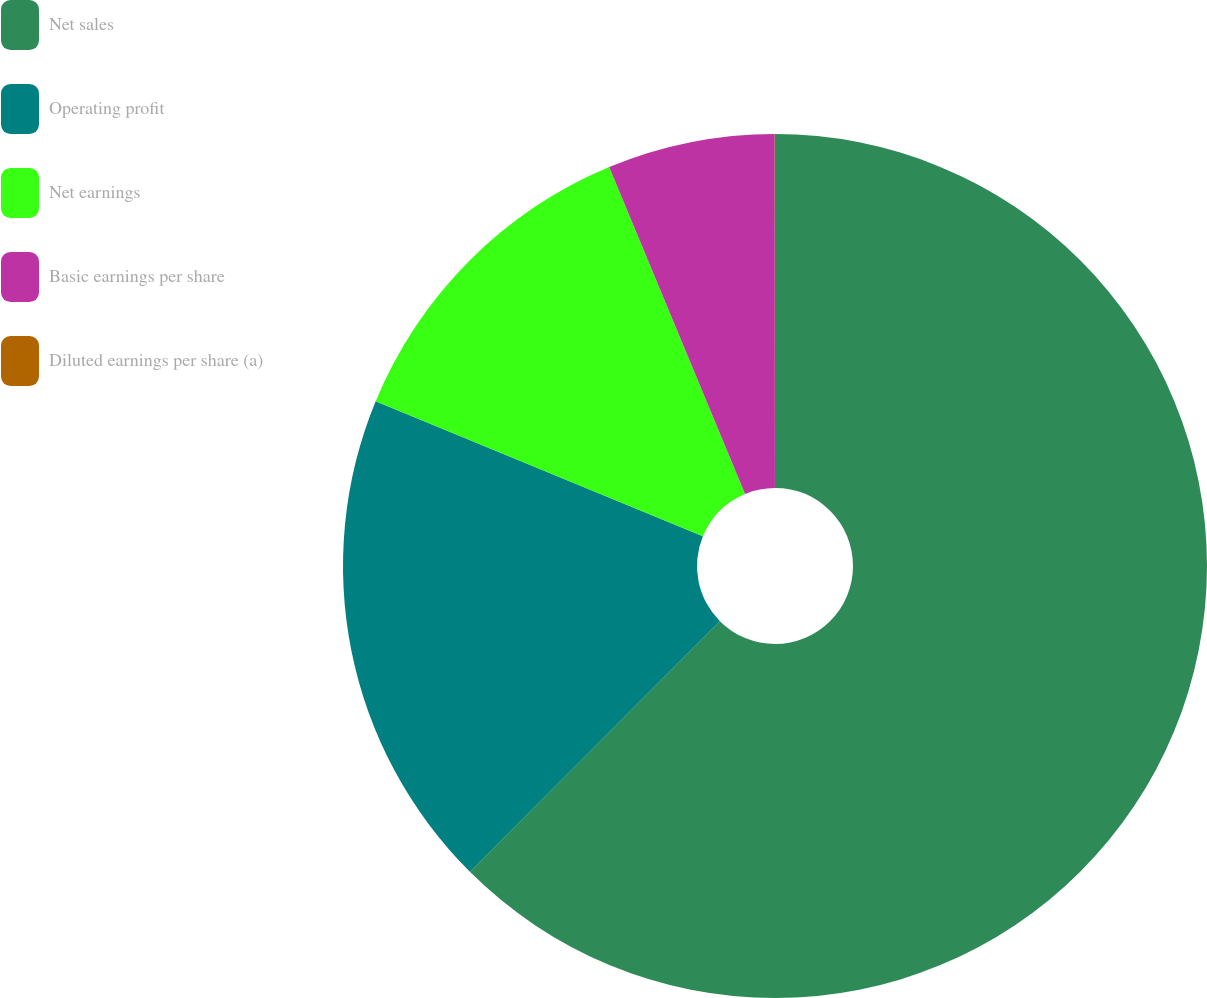<chart> <loc_0><loc_0><loc_500><loc_500><pie_chart><fcel>Net sales<fcel>Operating profit<fcel>Net earnings<fcel>Basic earnings per share<fcel>Diluted earnings per share (a)<nl><fcel>62.48%<fcel>18.75%<fcel>12.5%<fcel>6.26%<fcel>0.01%<nl></chart> 